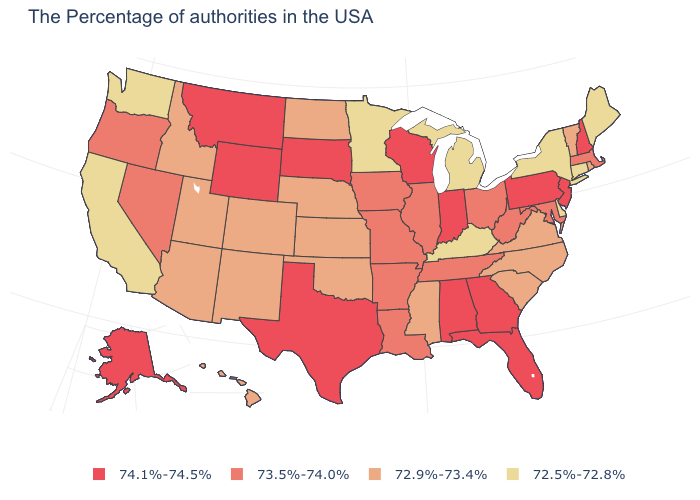Name the states that have a value in the range 72.9%-73.4%?
Quick response, please. Rhode Island, Vermont, Virginia, North Carolina, South Carolina, Mississippi, Kansas, Nebraska, Oklahoma, North Dakota, Colorado, New Mexico, Utah, Arizona, Idaho, Hawaii. What is the value of Hawaii?
Give a very brief answer. 72.9%-73.4%. Does the first symbol in the legend represent the smallest category?
Write a very short answer. No. What is the value of Virginia?
Give a very brief answer. 72.9%-73.4%. Among the states that border Mississippi , which have the lowest value?
Give a very brief answer. Tennessee, Louisiana, Arkansas. Which states have the lowest value in the USA?
Concise answer only. Maine, Connecticut, New York, Delaware, Michigan, Kentucky, Minnesota, California, Washington. What is the value of New Hampshire?
Concise answer only. 74.1%-74.5%. Name the states that have a value in the range 73.5%-74.0%?
Write a very short answer. Massachusetts, Maryland, West Virginia, Ohio, Tennessee, Illinois, Louisiana, Missouri, Arkansas, Iowa, Nevada, Oregon. What is the value of South Carolina?
Keep it brief. 72.9%-73.4%. What is the value of Washington?
Write a very short answer. 72.5%-72.8%. Name the states that have a value in the range 72.5%-72.8%?
Write a very short answer. Maine, Connecticut, New York, Delaware, Michigan, Kentucky, Minnesota, California, Washington. What is the lowest value in states that border Illinois?
Quick response, please. 72.5%-72.8%. Which states have the lowest value in the USA?
Quick response, please. Maine, Connecticut, New York, Delaware, Michigan, Kentucky, Minnesota, California, Washington. Name the states that have a value in the range 72.9%-73.4%?
Write a very short answer. Rhode Island, Vermont, Virginia, North Carolina, South Carolina, Mississippi, Kansas, Nebraska, Oklahoma, North Dakota, Colorado, New Mexico, Utah, Arizona, Idaho, Hawaii. What is the value of Minnesota?
Quick response, please. 72.5%-72.8%. 